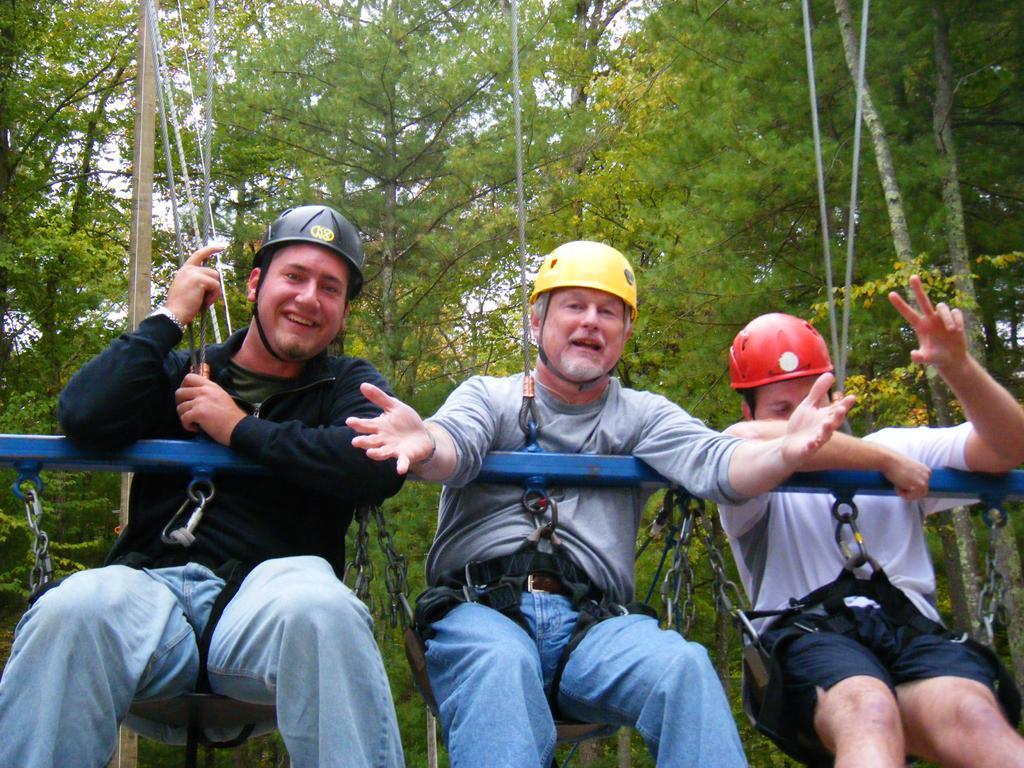How would you summarize this image in a sentence or two? Here I can see three men smiling and swinging. I can see the ropes to the swings. In front of these people there is a metal rod. In the background, I can see many trees. 